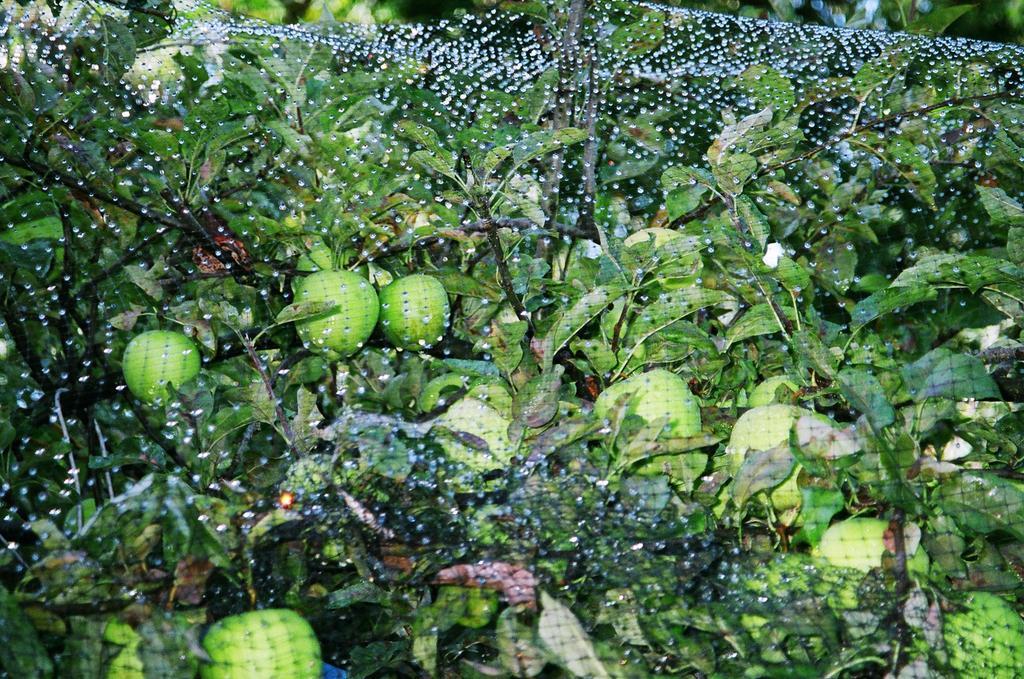Describe this image in one or two sentences. In this image we can see plants with fruits and there is a net. 